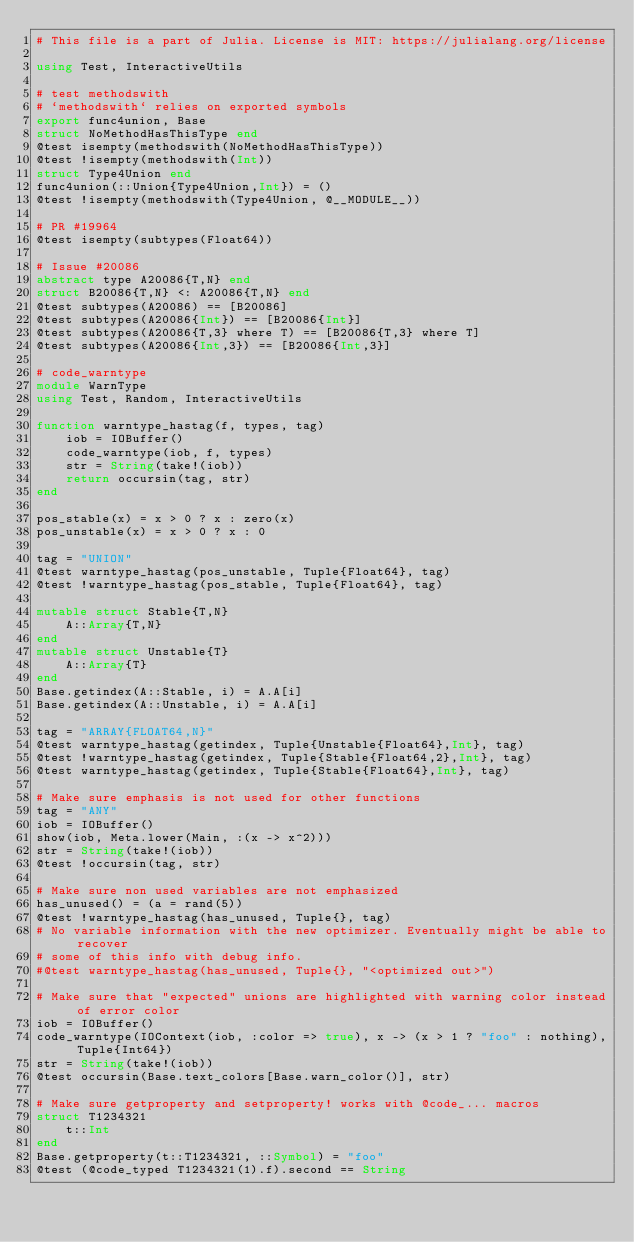<code> <loc_0><loc_0><loc_500><loc_500><_Julia_># This file is a part of Julia. License is MIT: https://julialang.org/license

using Test, InteractiveUtils

# test methodswith
# `methodswith` relies on exported symbols
export func4union, Base
struct NoMethodHasThisType end
@test isempty(methodswith(NoMethodHasThisType))
@test !isempty(methodswith(Int))
struct Type4Union end
func4union(::Union{Type4Union,Int}) = ()
@test !isempty(methodswith(Type4Union, @__MODULE__))

# PR #19964
@test isempty(subtypes(Float64))

# Issue #20086
abstract type A20086{T,N} end
struct B20086{T,N} <: A20086{T,N} end
@test subtypes(A20086) == [B20086]
@test subtypes(A20086{Int}) == [B20086{Int}]
@test subtypes(A20086{T,3} where T) == [B20086{T,3} where T]
@test subtypes(A20086{Int,3}) == [B20086{Int,3}]

# code_warntype
module WarnType
using Test, Random, InteractiveUtils

function warntype_hastag(f, types, tag)
    iob = IOBuffer()
    code_warntype(iob, f, types)
    str = String(take!(iob))
    return occursin(tag, str)
end

pos_stable(x) = x > 0 ? x : zero(x)
pos_unstable(x) = x > 0 ? x : 0

tag = "UNION"
@test warntype_hastag(pos_unstable, Tuple{Float64}, tag)
@test !warntype_hastag(pos_stable, Tuple{Float64}, tag)

mutable struct Stable{T,N}
    A::Array{T,N}
end
mutable struct Unstable{T}
    A::Array{T}
end
Base.getindex(A::Stable, i) = A.A[i]
Base.getindex(A::Unstable, i) = A.A[i]

tag = "ARRAY{FLOAT64,N}"
@test warntype_hastag(getindex, Tuple{Unstable{Float64},Int}, tag)
@test !warntype_hastag(getindex, Tuple{Stable{Float64,2},Int}, tag)
@test warntype_hastag(getindex, Tuple{Stable{Float64},Int}, tag)

# Make sure emphasis is not used for other functions
tag = "ANY"
iob = IOBuffer()
show(iob, Meta.lower(Main, :(x -> x^2)))
str = String(take!(iob))
@test !occursin(tag, str)

# Make sure non used variables are not emphasized
has_unused() = (a = rand(5))
@test !warntype_hastag(has_unused, Tuple{}, tag)
# No variable information with the new optimizer. Eventually might be able to recover
# some of this info with debug info.
#@test warntype_hastag(has_unused, Tuple{}, "<optimized out>")

# Make sure that "expected" unions are highlighted with warning color instead of error color
iob = IOBuffer()
code_warntype(IOContext(iob, :color => true), x -> (x > 1 ? "foo" : nothing), Tuple{Int64})
str = String(take!(iob))
@test occursin(Base.text_colors[Base.warn_color()], str)

# Make sure getproperty and setproperty! works with @code_... macros
struct T1234321
    t::Int
end
Base.getproperty(t::T1234321, ::Symbol) = "foo"
@test (@code_typed T1234321(1).f).second == String</code> 